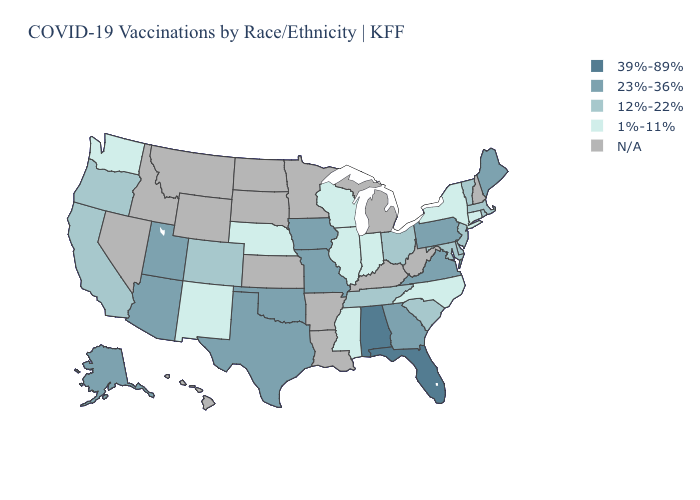Does Washington have the highest value in the West?
Quick response, please. No. Name the states that have a value in the range 1%-11%?
Concise answer only. Connecticut, Illinois, Indiana, Mississippi, Nebraska, New Mexico, New York, North Carolina, Washington, Wisconsin. Does Illinois have the lowest value in the USA?
Be succinct. Yes. Does Vermont have the lowest value in the Northeast?
Concise answer only. No. Which states have the highest value in the USA?
Give a very brief answer. Alabama, Florida. Name the states that have a value in the range 1%-11%?
Write a very short answer. Connecticut, Illinois, Indiana, Mississippi, Nebraska, New Mexico, New York, North Carolina, Washington, Wisconsin. Name the states that have a value in the range 12%-22%?
Give a very brief answer. California, Colorado, Delaware, Maryland, Massachusetts, New Jersey, Ohio, Oregon, Rhode Island, South Carolina, Tennessee, Vermont. What is the lowest value in states that border Virginia?
Give a very brief answer. 1%-11%. Which states have the highest value in the USA?
Quick response, please. Alabama, Florida. What is the value of Iowa?
Write a very short answer. 23%-36%. Name the states that have a value in the range 1%-11%?
Give a very brief answer. Connecticut, Illinois, Indiana, Mississippi, Nebraska, New Mexico, New York, North Carolina, Washington, Wisconsin. Name the states that have a value in the range 39%-89%?
Be succinct. Alabama, Florida. What is the lowest value in the Northeast?
Answer briefly. 1%-11%. Name the states that have a value in the range 23%-36%?
Write a very short answer. Alaska, Arizona, Georgia, Iowa, Maine, Missouri, Oklahoma, Pennsylvania, Texas, Utah, Virginia. Which states have the highest value in the USA?
Give a very brief answer. Alabama, Florida. 